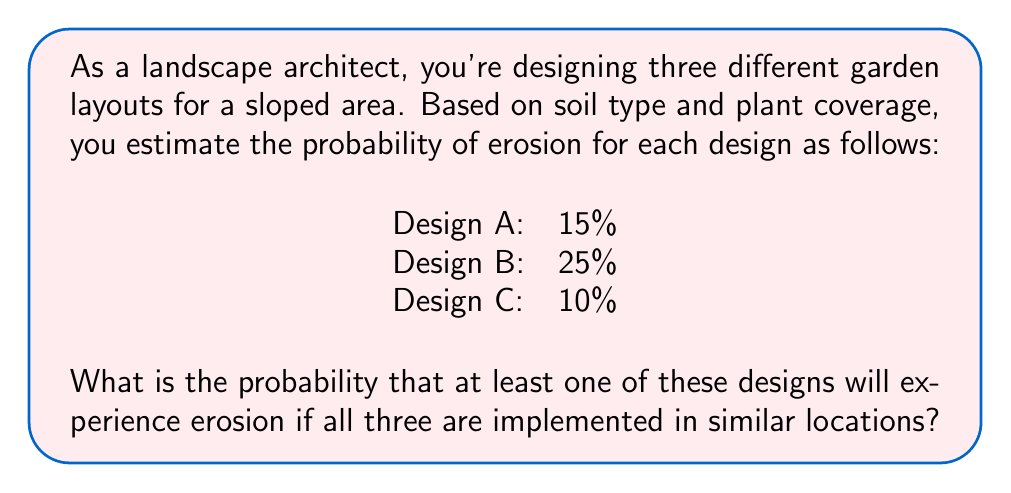Can you solve this math problem? To solve this problem, we'll use the complement of the probability that none of the designs experience erosion.

Step 1: Calculate the probability that Design A does not experience erosion.
$P(\text{No erosion A}) = 1 - 0.15 = 0.85$

Step 2: Calculate the probability that Design B does not experience erosion.
$P(\text{No erosion B}) = 1 - 0.25 = 0.75$

Step 3: Calculate the probability that Design C does not experience erosion.
$P(\text{No erosion C}) = 1 - 0.10 = 0.90$

Step 4: Calculate the probability that none of the designs experience erosion.
$P(\text{No erosion in any}) = P(\text{No erosion A}) \times P(\text{No erosion B}) \times P(\text{No erosion C})$
$P(\text{No erosion in any}) = 0.85 \times 0.75 \times 0.90 = 0.57375$

Step 5: Calculate the probability that at least one design experiences erosion.
$P(\text{At least one erosion}) = 1 - P(\text{No erosion in any})$
$P(\text{At least one erosion}) = 1 - 0.57375 = 0.42625$

Step 6: Convert to a percentage.
$0.42625 \times 100\% = 42.625\%$
Answer: 42.625% 